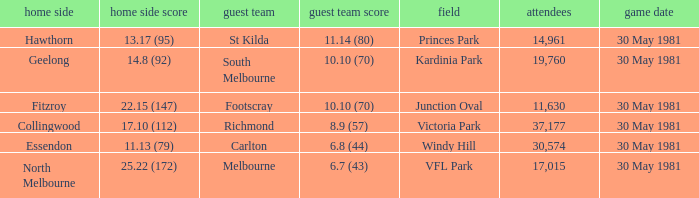What did carlton score while away? 6.8 (44). 